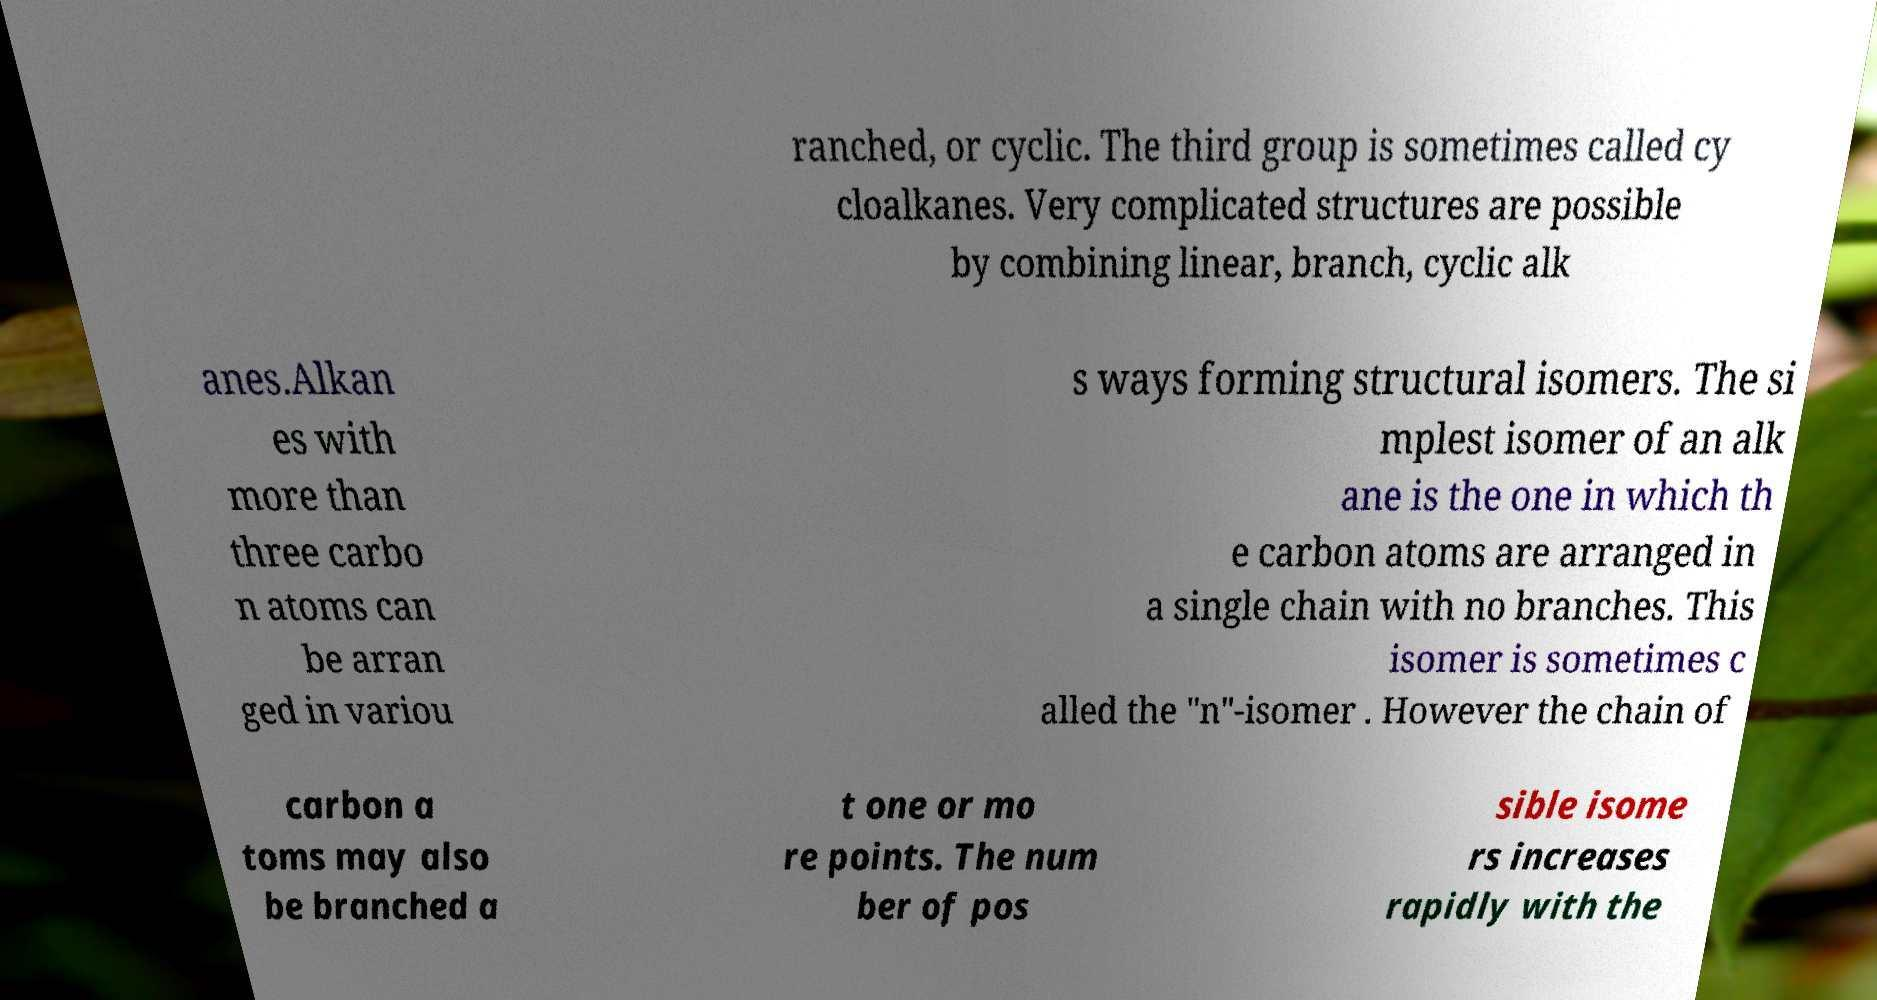Please identify and transcribe the text found in this image. ranched, or cyclic. The third group is sometimes called cy cloalkanes. Very complicated structures are possible by combining linear, branch, cyclic alk anes.Alkan es with more than three carbo n atoms can be arran ged in variou s ways forming structural isomers. The si mplest isomer of an alk ane is the one in which th e carbon atoms are arranged in a single chain with no branches. This isomer is sometimes c alled the "n"-isomer . However the chain of carbon a toms may also be branched a t one or mo re points. The num ber of pos sible isome rs increases rapidly with the 